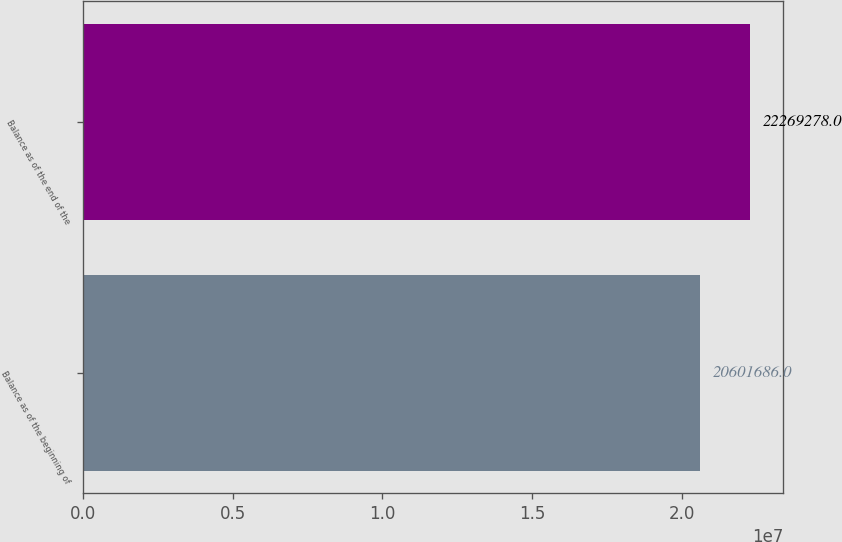<chart> <loc_0><loc_0><loc_500><loc_500><bar_chart><fcel>Balance as of the beginning of<fcel>Balance as of the end of the<nl><fcel>2.06017e+07<fcel>2.22693e+07<nl></chart> 